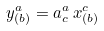<formula> <loc_0><loc_0><loc_500><loc_500>y ^ { a } _ { ( b ) } = \L a ^ { a } _ { c } \, x ^ { c } _ { ( b ) }</formula> 